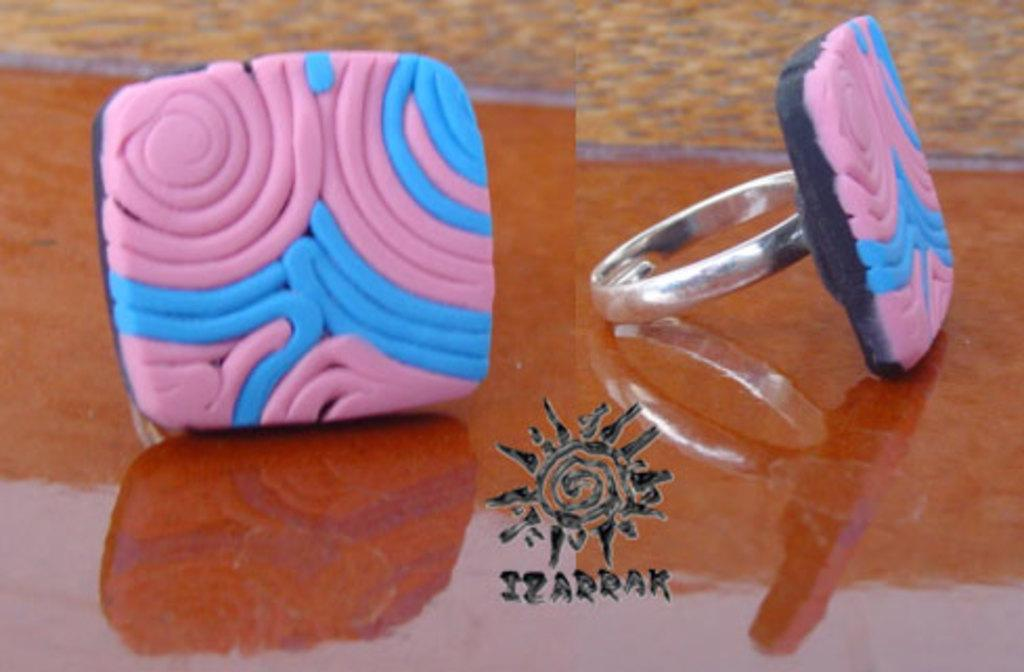What piece of furniture is present in the image? There is a table in the image. What items are on the table? There are two finger rings on the table. Can you describe the appearance of the finger rings? The finger rings have pink and white color lines on them. Is there a dog sitting next to the table in the image? No, there is no dog present in the image. Can you tell me how many doors are visible in the image? There are no doors visible in the image; it only features a table and two finger rings. 